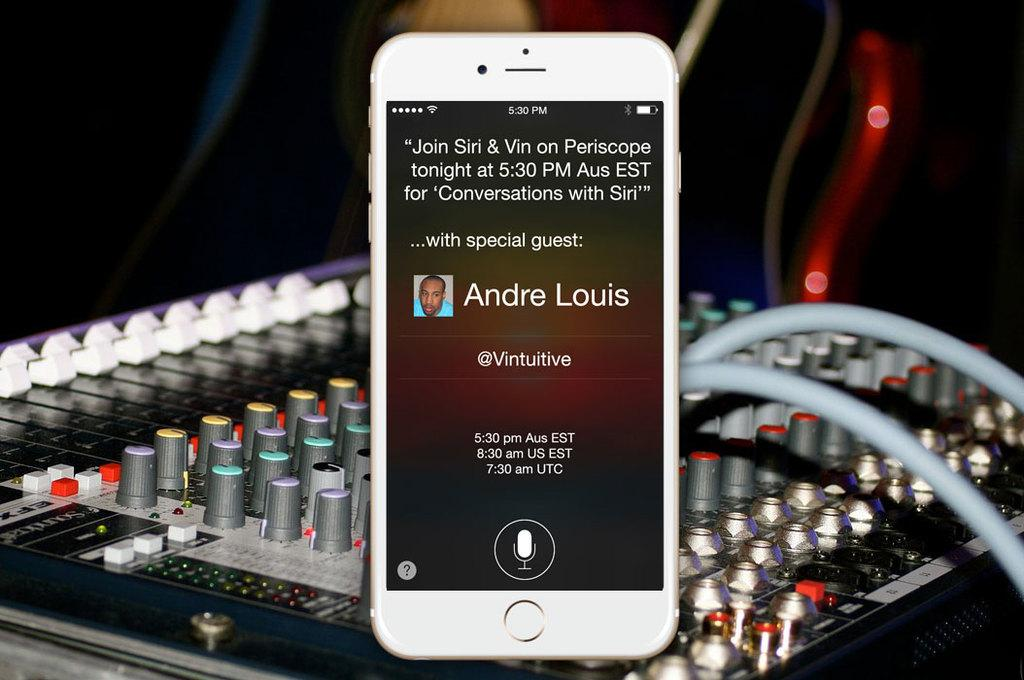<image>
Present a compact description of the photo's key features. On the screen of an Iphone is a reminder for a Periscope show at 5:30 PM with special guest Andre Louis. 